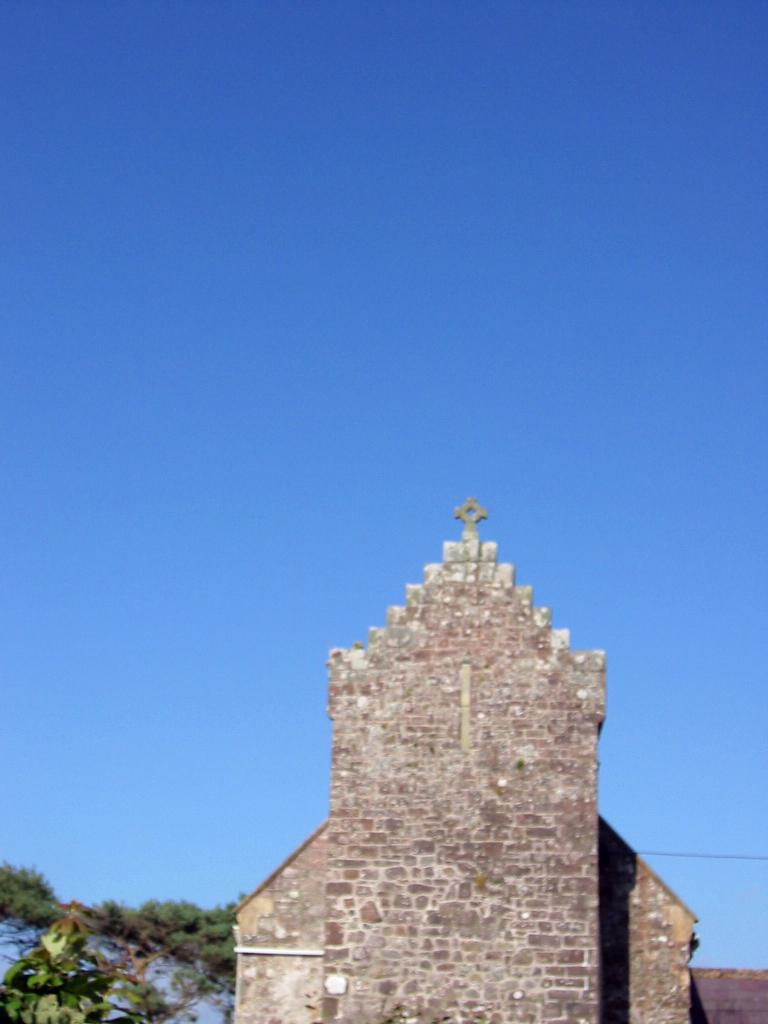What type of building is depicted at the bottom of the picture? The walls of a church are depicted at the bottom of the picture. What other natural elements can be seen in the picture? There are trees in the picture. What part of the natural environment is visible in the picture? The sky is visible in the picture. What type of muscle is being exercised by the trees in the picture? There are no muscles present in the image, as trees are plants and do not have muscles. 